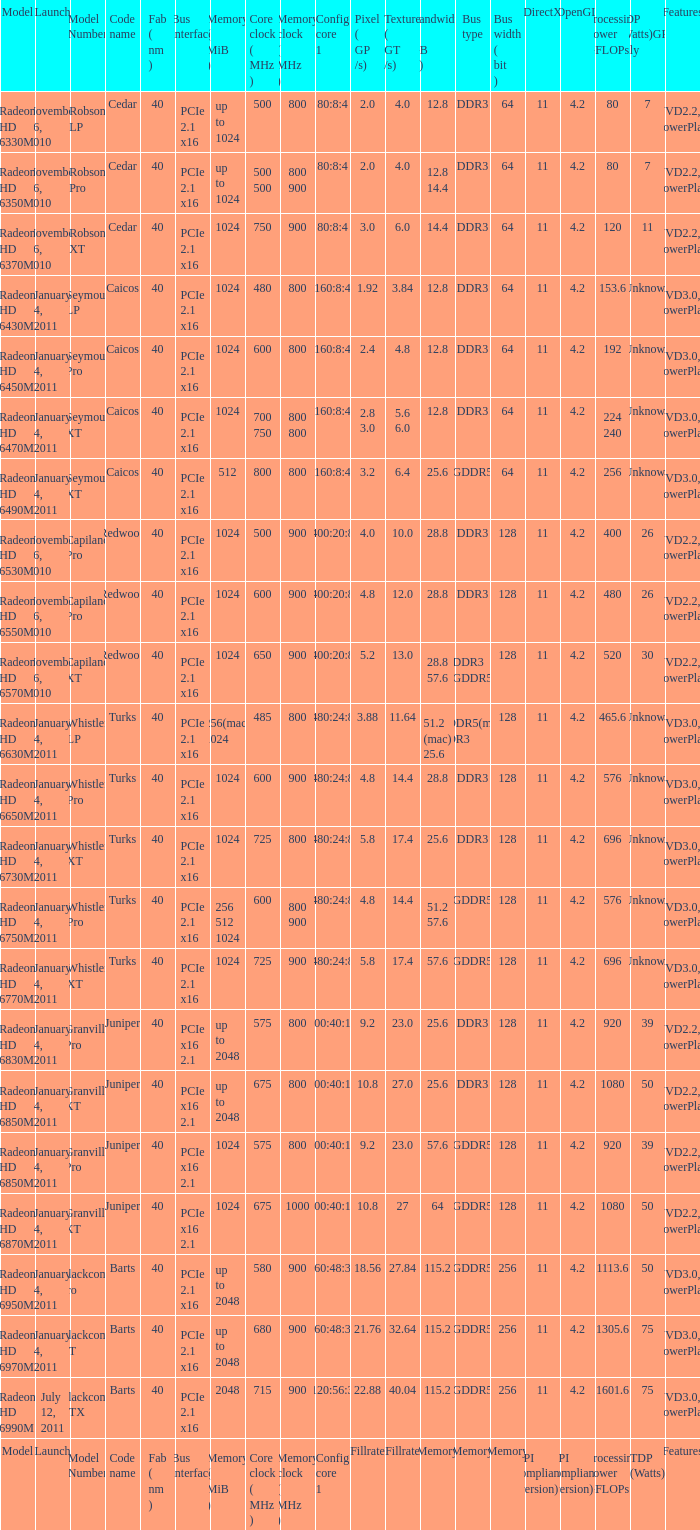List all the code names associated with the radeon hd 6650m model. Turks. Parse the table in full. {'header': ['Model', 'Launch', 'Model Number', 'Code name', 'Fab ( nm )', 'Bus interface', 'Memory ( MiB )', 'Core clock ( MHz )', 'Memory clock ( MHz )', 'Config core 1', 'Pixel ( GP /s)', 'Texture ( GT /s)', 'Bandwidth ( GB /s)', 'Bus type', 'Bus width ( bit )', 'DirectX', 'OpenGL', 'Processing Power GFLOPs', 'TDP (Watts)GPU only', 'Features'], 'rows': [['Radeon HD 6330M', 'November 26, 2010', 'Robson LP', 'Cedar', '40', 'PCIe 2.1 x16', 'up to 1024', '500', '800', '80:8:4', '2.0', '4.0', '12.8', 'DDR3', '64', '11', '4.2', '80', '7', 'UVD2.2, PowerPlay'], ['Radeon HD 6350M', 'November 26, 2010', 'Robson Pro', 'Cedar', '40', 'PCIe 2.1 x16', 'up to 1024', '500 500', '800 900', '80:8:4', '2.0', '4.0', '12.8 14.4', 'DDR3', '64', '11', '4.2', '80', '7', 'UVD2.2, PowerPlay'], ['Radeon HD 6370M', 'November 26, 2010', 'Robson XT', 'Cedar', '40', 'PCIe 2.1 x16', '1024', '750', '900', '80:8:4', '3.0', '6.0', '14.4', 'DDR3', '64', '11', '4.2', '120', '11', 'UVD2.2, PowerPlay'], ['Radeon HD 6430M', 'January 4, 2011', 'Seymour LP', 'Caicos', '40', 'PCIe 2.1 x16', '1024', '480', '800', '160:8:4', '1.92', '3.84', '12.8', 'DDR3', '64', '11', '4.2', '153.6', 'Unknown', 'UVD3.0, PowerPlay'], ['Radeon HD 6450M', 'January 4, 2011', 'Seymour Pro', 'Caicos', '40', 'PCIe 2.1 x16', '1024', '600', '800', '160:8:4', '2.4', '4.8', '12.8', 'DDR3', '64', '11', '4.2', '192', 'Unknown', 'UVD3.0, PowerPlay'], ['Radeon HD 6470M', 'January 4, 2011', 'Seymour XT', 'Caicos', '40', 'PCIe 2.1 x16', '1024', '700 750', '800 800', '160:8:4', '2.8 3.0', '5.6 6.0', '12.8', 'DDR3', '64', '11', '4.2', '224 240', 'Unknown', 'UVD3.0, PowerPlay'], ['Radeon HD 6490M', 'January 4, 2011', 'Seymour XT', 'Caicos', '40', 'PCIe 2.1 x16', '512', '800', '800', '160:8:4', '3.2', '6.4', '25.6', 'GDDR5', '64', '11', '4.2', '256', 'Unknown', 'UVD3.0, PowerPlay'], ['Radeon HD 6530M', 'November 26, 2010', 'Capilano Pro', 'Redwood', '40', 'PCIe 2.1 x16', '1024', '500', '900', '400:20:8', '4.0', '10.0', '28.8', 'DDR3', '128', '11', '4.2', '400', '26', 'UVD2.2, PowerPlay'], ['Radeon HD 6550M', 'November 26, 2010', 'Capilano Pro', 'Redwood', '40', 'PCIe 2.1 x16', '1024', '600', '900', '400:20:8', '4.8', '12.0', '28.8', 'DDR3', '128', '11', '4.2', '480', '26', 'UVD2.2, PowerPlay'], ['Radeon HD 6570M', 'November 26, 2010', 'Capilano XT', 'Redwood', '40', 'PCIe 2.1 x16', '1024', '650', '900', '400:20:8', '5.2', '13.0', '28.8 57.6', 'DDR3 GDDR5', '128', '11', '4.2', '520', '30', 'UVD2.2, PowerPlay'], ['Radeon HD 6630M', 'January 4, 2011', 'Whistler LP', 'Turks', '40', 'PCIe 2.1 x16', '256(mac) 1024', '485', '800', '480:24:8', '3.88', '11.64', '51.2 (mac) 25.6', 'GDDR5(mac) DDR3', '128', '11', '4.2', '465.6', 'Unknown', 'UVD3.0, PowerPlay'], ['Radeon HD 6650M', 'January 4, 2011', 'Whistler Pro', 'Turks', '40', 'PCIe 2.1 x16', '1024', '600', '900', '480:24:8', '4.8', '14.4', '28.8', 'DDR3', '128', '11', '4.2', '576', 'Unknown', 'UVD3.0, PowerPlay'], ['Radeon HD 6730M', 'January 4, 2011', 'Whistler XT', 'Turks', '40', 'PCIe 2.1 x16', '1024', '725', '800', '480:24:8', '5.8', '17.4', '25.6', 'DDR3', '128', '11', '4.2', '696', 'Unknown', 'UVD3.0, PowerPlay'], ['Radeon HD 6750M', 'January 4, 2011', 'Whistler Pro', 'Turks', '40', 'PCIe 2.1 x16', '256 512 1024', '600', '800 900', '480:24:8', '4.8', '14.4', '51.2 57.6', 'GDDR5', '128', '11', '4.2', '576', 'Unknown', 'UVD3.0, PowerPlay'], ['Radeon HD 6770M', 'January 4, 2011', 'Whistler XT', 'Turks', '40', 'PCIe 2.1 x16', '1024', '725', '900', '480:24:8', '5.8', '17.4', '57.6', 'GDDR5', '128', '11', '4.2', '696', 'Unknown', 'UVD3.0, PowerPlay'], ['Radeon HD 6830M', 'January 4, 2011', 'Granville Pro', 'Juniper', '40', 'PCIe x16 2.1', 'up to 2048', '575', '800', '800:40:16', '9.2', '23.0', '25.6', 'DDR3', '128', '11', '4.2', '920', '39', 'UVD2.2, PowerPlay'], ['Radeon HD 6850M', 'January 4, 2011', 'Granville XT', 'Juniper', '40', 'PCIe x16 2.1', 'up to 2048', '675', '800', '800:40:16', '10.8', '27.0', '25.6', 'DDR3', '128', '11', '4.2', '1080', '50', 'UVD2.2, PowerPlay'], ['Radeon HD 6850M', 'January 4, 2011', 'Granville Pro', 'Juniper', '40', 'PCIe x16 2.1', '1024', '575', '800', '800:40:16', '9.2', '23.0', '57.6', 'GDDR5', '128', '11', '4.2', '920', '39', 'UVD2.2, PowerPlay'], ['Radeon HD 6870M', 'January 4, 2011', 'Granville XT', 'Juniper', '40', 'PCIe x16 2.1', '1024', '675', '1000', '800:40:16', '10.8', '27', '64', 'GDDR5', '128', '11', '4.2', '1080', '50', 'UVD2.2, PowerPlay'], ['Radeon HD 6950M', 'January 4, 2011', 'Blackcomb Pro', 'Barts', '40', 'PCIe 2.1 x16', 'up to 2048', '580', '900', '960:48:32', '18.56', '27.84', '115.2', 'GDDR5', '256', '11', '4.2', '1113.6', '50', 'UVD3.0, PowerPlay'], ['Radeon HD 6970M', 'January 4, 2011', 'Blackcomb XT', 'Barts', '40', 'PCIe 2.1 x16', 'up to 2048', '680', '900', '960:48:32', '21.76', '32.64', '115.2', 'GDDR5', '256', '11', '4.2', '1305.6', '75', 'UVD3.0, PowerPlay'], ['Radeon HD 6990M', 'July 12, 2011', 'Blackcomb XTX', 'Barts', '40', 'PCIe 2.1 x16', '2048', '715', '900', '1120:56:32', '22.88', '40.04', '115.2', 'GDDR5', '256', '11', '4.2', '1601.6', '75', 'UVD3.0, PowerPlay'], ['Model', 'Launch', 'Model Number', 'Code name', 'Fab ( nm )', 'Bus interface', 'Memory ( MiB )', 'Core clock ( MHz )', 'Memory clock ( MHz )', 'Config core 1', 'Fillrate', 'Fillrate', 'Memory', 'Memory', 'Memory', 'API compliance (version)', 'API compliance (version)', 'Processing Power GFLOPs', 'TDP (Watts)', 'Features']]} 